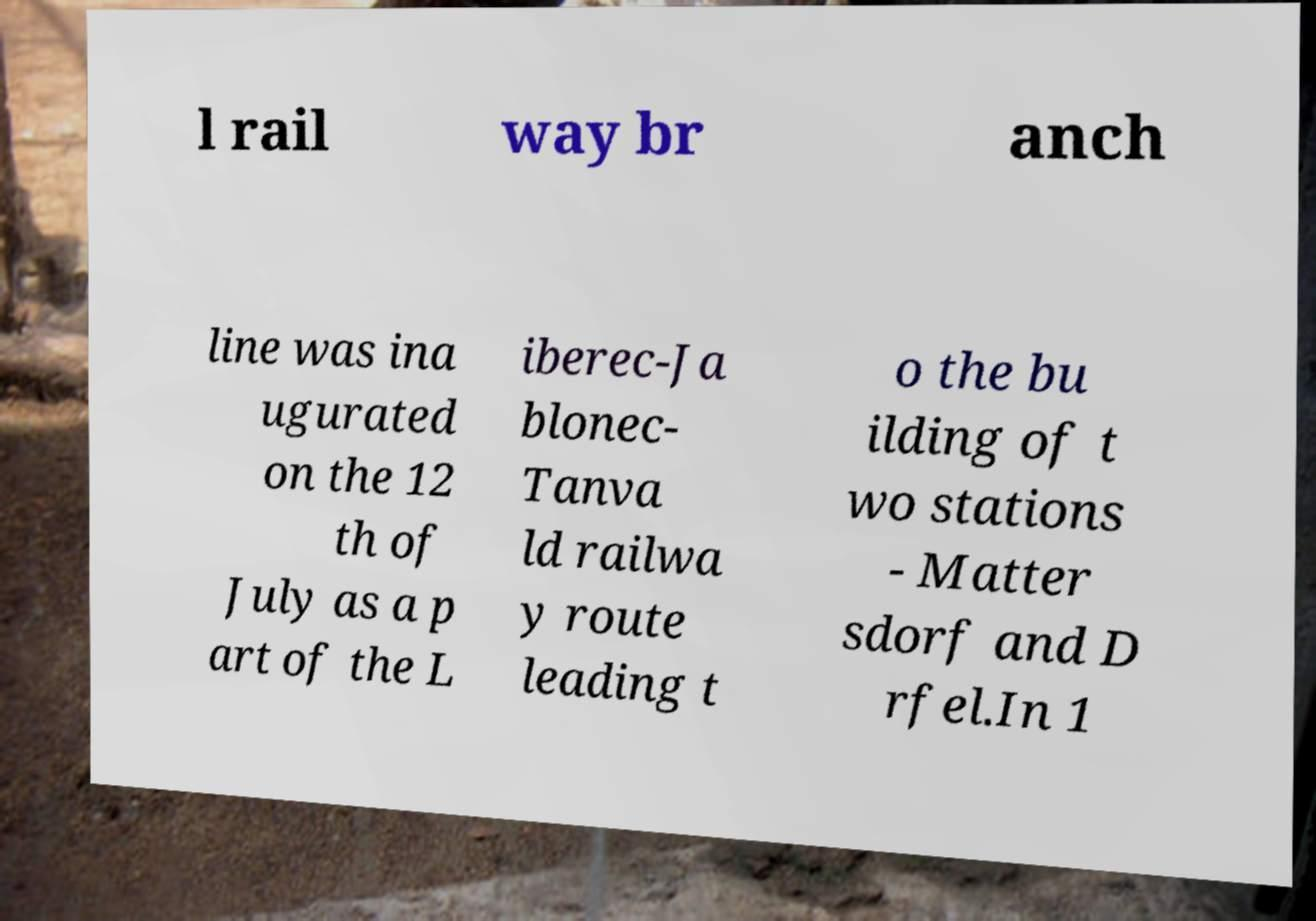For documentation purposes, I need the text within this image transcribed. Could you provide that? l rail way br anch line was ina ugurated on the 12 th of July as a p art of the L iberec-Ja blonec- Tanva ld railwa y route leading t o the bu ilding of t wo stations - Matter sdorf and D rfel.In 1 